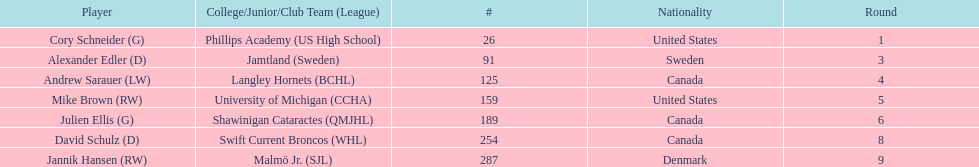What is the name of the last player on this chart? Jannik Hansen (RW). 